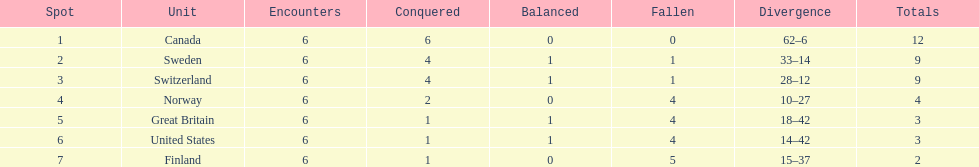How many teams won 6 matches? 1. Would you mind parsing the complete table? {'header': ['Spot', 'Unit', 'Encounters', 'Conquered', 'Balanced', 'Fallen', 'Divergence', 'Totals'], 'rows': [['1', 'Canada', '6', '6', '0', '0', '62–6', '12'], ['2', 'Sweden', '6', '4', '1', '1', '33–14', '9'], ['3', 'Switzerland', '6', '4', '1', '1', '28–12', '9'], ['4', 'Norway', '6', '2', '0', '4', '10–27', '4'], ['5', 'Great Britain', '6', '1', '1', '4', '18–42', '3'], ['6', 'United States', '6', '1', '1', '4', '14–42', '3'], ['7', 'Finland', '6', '1', '0', '5', '15–37', '2']]} 